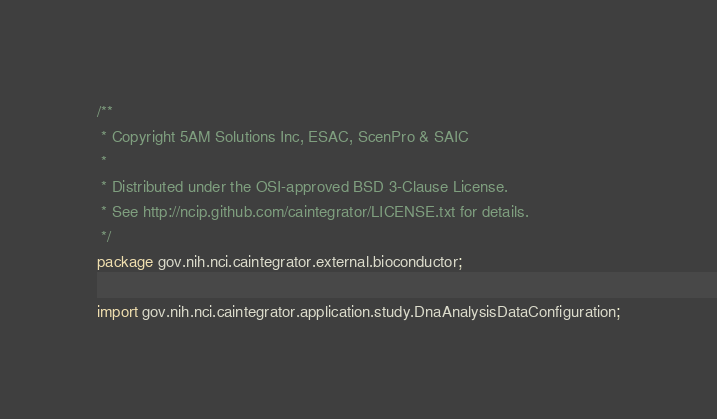Convert code to text. <code><loc_0><loc_0><loc_500><loc_500><_Java_>/**
 * Copyright 5AM Solutions Inc, ESAC, ScenPro & SAIC
 *
 * Distributed under the OSI-approved BSD 3-Clause License.
 * See http://ncip.github.com/caintegrator/LICENSE.txt for details.
 */
package gov.nih.nci.caintegrator.external.bioconductor;

import gov.nih.nci.caintegrator.application.study.DnaAnalysisDataConfiguration;</code> 